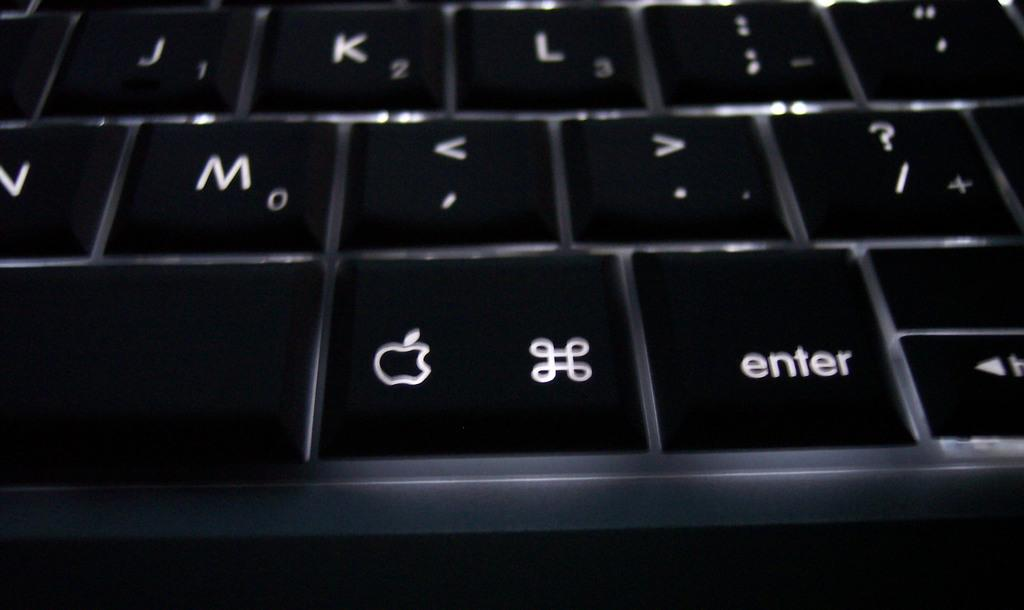What is the main object in the image? There is a keyboard in the image. What can be found on the keyboard? The keyboard has letters and symbols on it. What type of pen is being used by the laborer on the plane in the image? There is no pen, laborer, or plane present in the image; it only features a keyboard with letters and symbols. 